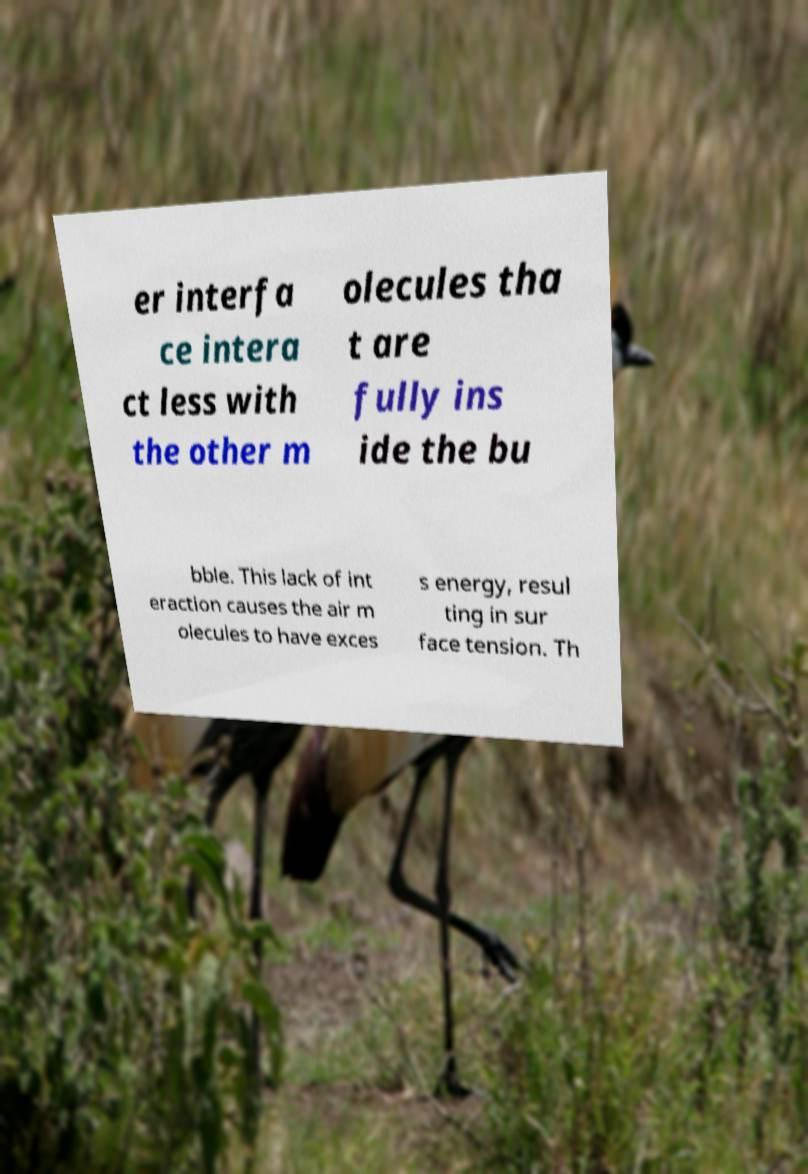What messages or text are displayed in this image? I need them in a readable, typed format. er interfa ce intera ct less with the other m olecules tha t are fully ins ide the bu bble. This lack of int eraction causes the air m olecules to have exces s energy, resul ting in sur face tension. Th 